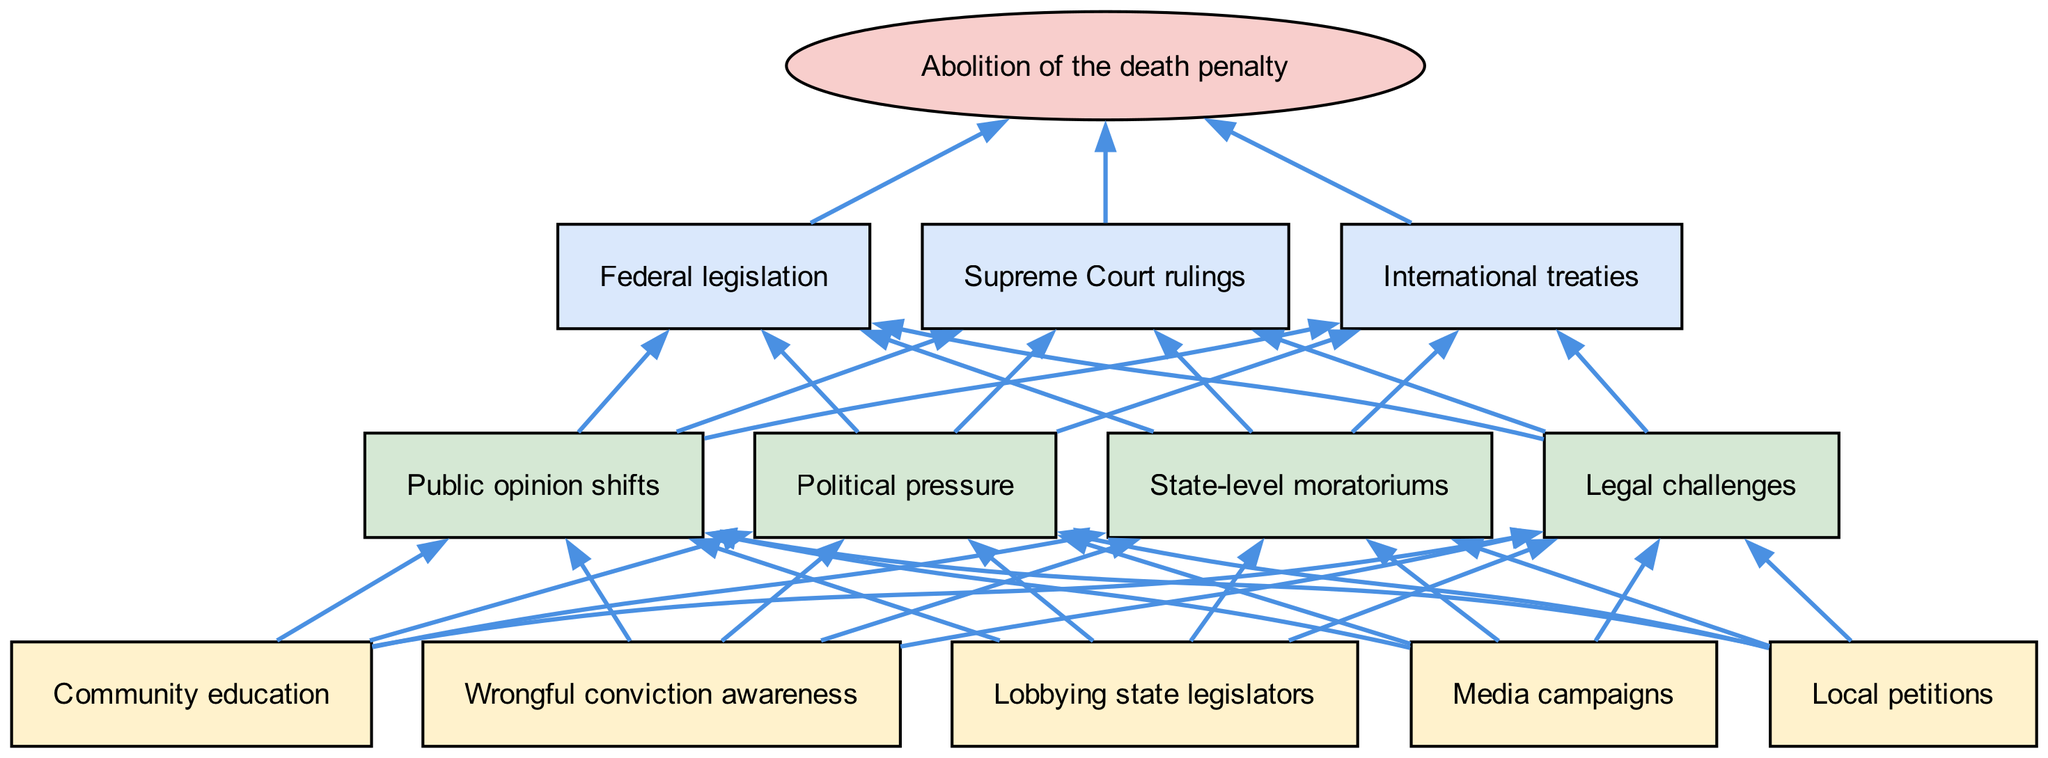What is the final outcome depicted in the diagram? The final outcome node at the top of the diagram is explicitly labeled, clearly indicating the end result of the process outlined in the flow chart.
Answer: Abolition of the death penalty How many nodes are there in the bottom level? Carefully counting the individual nodes in the bottom level of the flow chart indicates there are five specific actions listed that contribute to the movement towards abolishing the death penalty.
Answer: 5 What connects local petitions to state-level moratoriums? Tracing the connections from the bottom level, local petitions are directly linked to state-level moratoriums through a series of edges representing the flow of advocacy efforts toward higher levels of change.
Answer: State-level moratoriums How many edges connect the middle level to the top level? Examining the connections (edges) between the middle level nodes and the top level nodes shows there are four distinct middle level actions leading to connections with three top level outcomes, allowing for multiple edges from middle to top.
Answer: 12 Which two top-level outcomes are connected by edges from the middle level? Looking at the diagram, the middle level connects to three top-level outcomes; tracing the edges shows that both federal legislation and supreme court rulings are connected, indicating they derive from advocacy efforts.
Answer: Federal legislation, Supreme Court rulings What is the relationship between wrongful conviction awareness and political pressure? The flow chart indicates that wrongful conviction awareness is part of the bottom level actions, which collectively feed into the middle level where political pressure is listed, establishing a cause-and-effect relationship between public awareness and legal action.
Answer: Political pressure What is the significance of community education in the diagram? The node for community education at the bottom level serves as a foundational element, influencing other middle level actions such as public opinion shifts, highlighting its importance in creating broader support for changes in the death penalty policy.
Answer: Public opinion shifts Which bottom-level action directly leads to legal challenges? Tracing the edges of the diagram shows that while multiple bottom-level actions connect to the middle level, the action that leads directly to legal challenges is the lobbying of state legislators, indicating a specific pathway to legal remedy.
Answer: Lobbying state legislators 